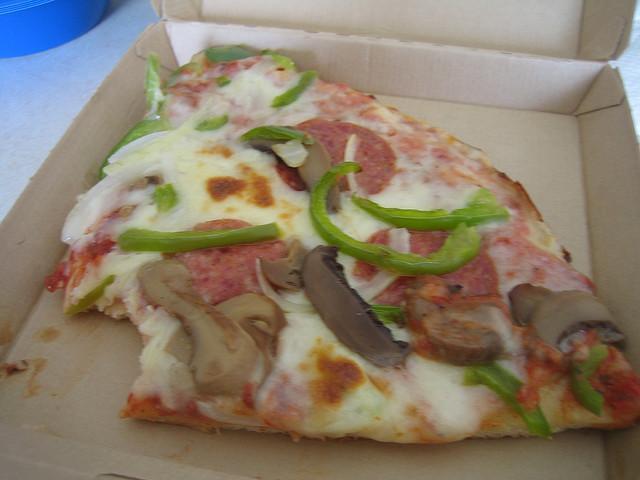How many vegetables are in this scene?
Give a very brief answer. 2. How many pizzas are visible?
Give a very brief answer. 1. 